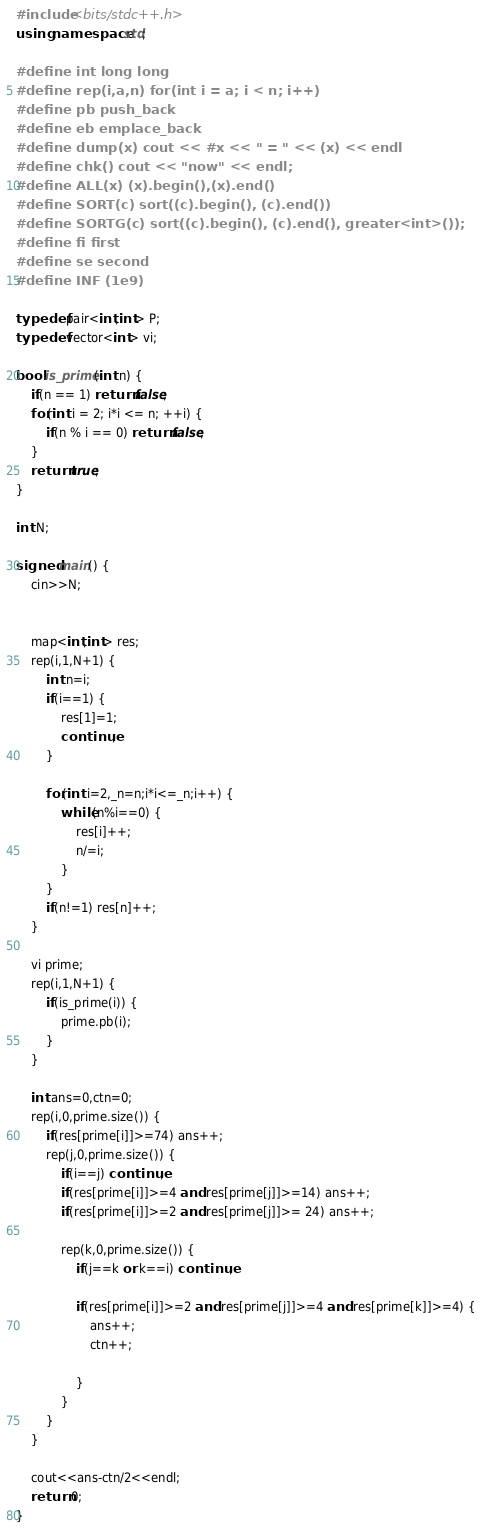Convert code to text. <code><loc_0><loc_0><loc_500><loc_500><_C++_>#include <bits/stdc++.h>
using namespace std;

#define int long long
#define rep(i,a,n) for(int i = a; i < n; i++)
#define pb push_back
#define eb emplace_back
#define dump(x) cout << #x << " = " << (x) << endl
#define chk() cout << "now" << endl;
#define ALL(x) (x).begin(),(x).end()
#define SORT(c) sort((c).begin(), (c).end())
#define SORTG(c) sort((c).begin(), (c).end(), greater<int>());
#define fi first
#define se second
#define INF (1e9)

typedef pair<int,int> P;
typedef vector<int> vi;

bool is_prime(int n) {
    if(n == 1) return false; 
    for(int i = 2; i*i <= n; ++i) {
        if(n % i == 0) return false;
    }
    return true;
}

int N;

signed main() {
    cin>>N;


    map<int,int> res;
    rep(i,1,N+1) {
        int n=i;
        if(i==1) {
            res[1]=1;
            continue;
        }

        for(int i=2,_n=n;i*i<=_n;i++) {
            while(n%i==0) {
                res[i]++;
                n/=i;
            }
        }
        if(n!=1) res[n]++;
    }

    vi prime;
    rep(i,1,N+1) {
        if(is_prime(i)) {
            prime.pb(i);
        }
    }
   
    int ans=0,ctn=0;
    rep(i,0,prime.size()) {
        if(res[prime[i]]>=74) ans++;
        rep(j,0,prime.size()) {
            if(i==j) continue;
            if(res[prime[i]]>=4 and res[prime[j]]>=14) ans++;
            if(res[prime[i]]>=2 and res[prime[j]]>= 24) ans++;

            rep(k,0,prime.size()) {
                if(j==k or k==i) continue;

                if(res[prime[i]]>=2 and res[prime[j]]>=4 and res[prime[k]]>=4) {
                    ans++;
                    ctn++;

                }
            }
        }
    }

    cout<<ans-ctn/2<<endl;
    return 0;
}



</code> 